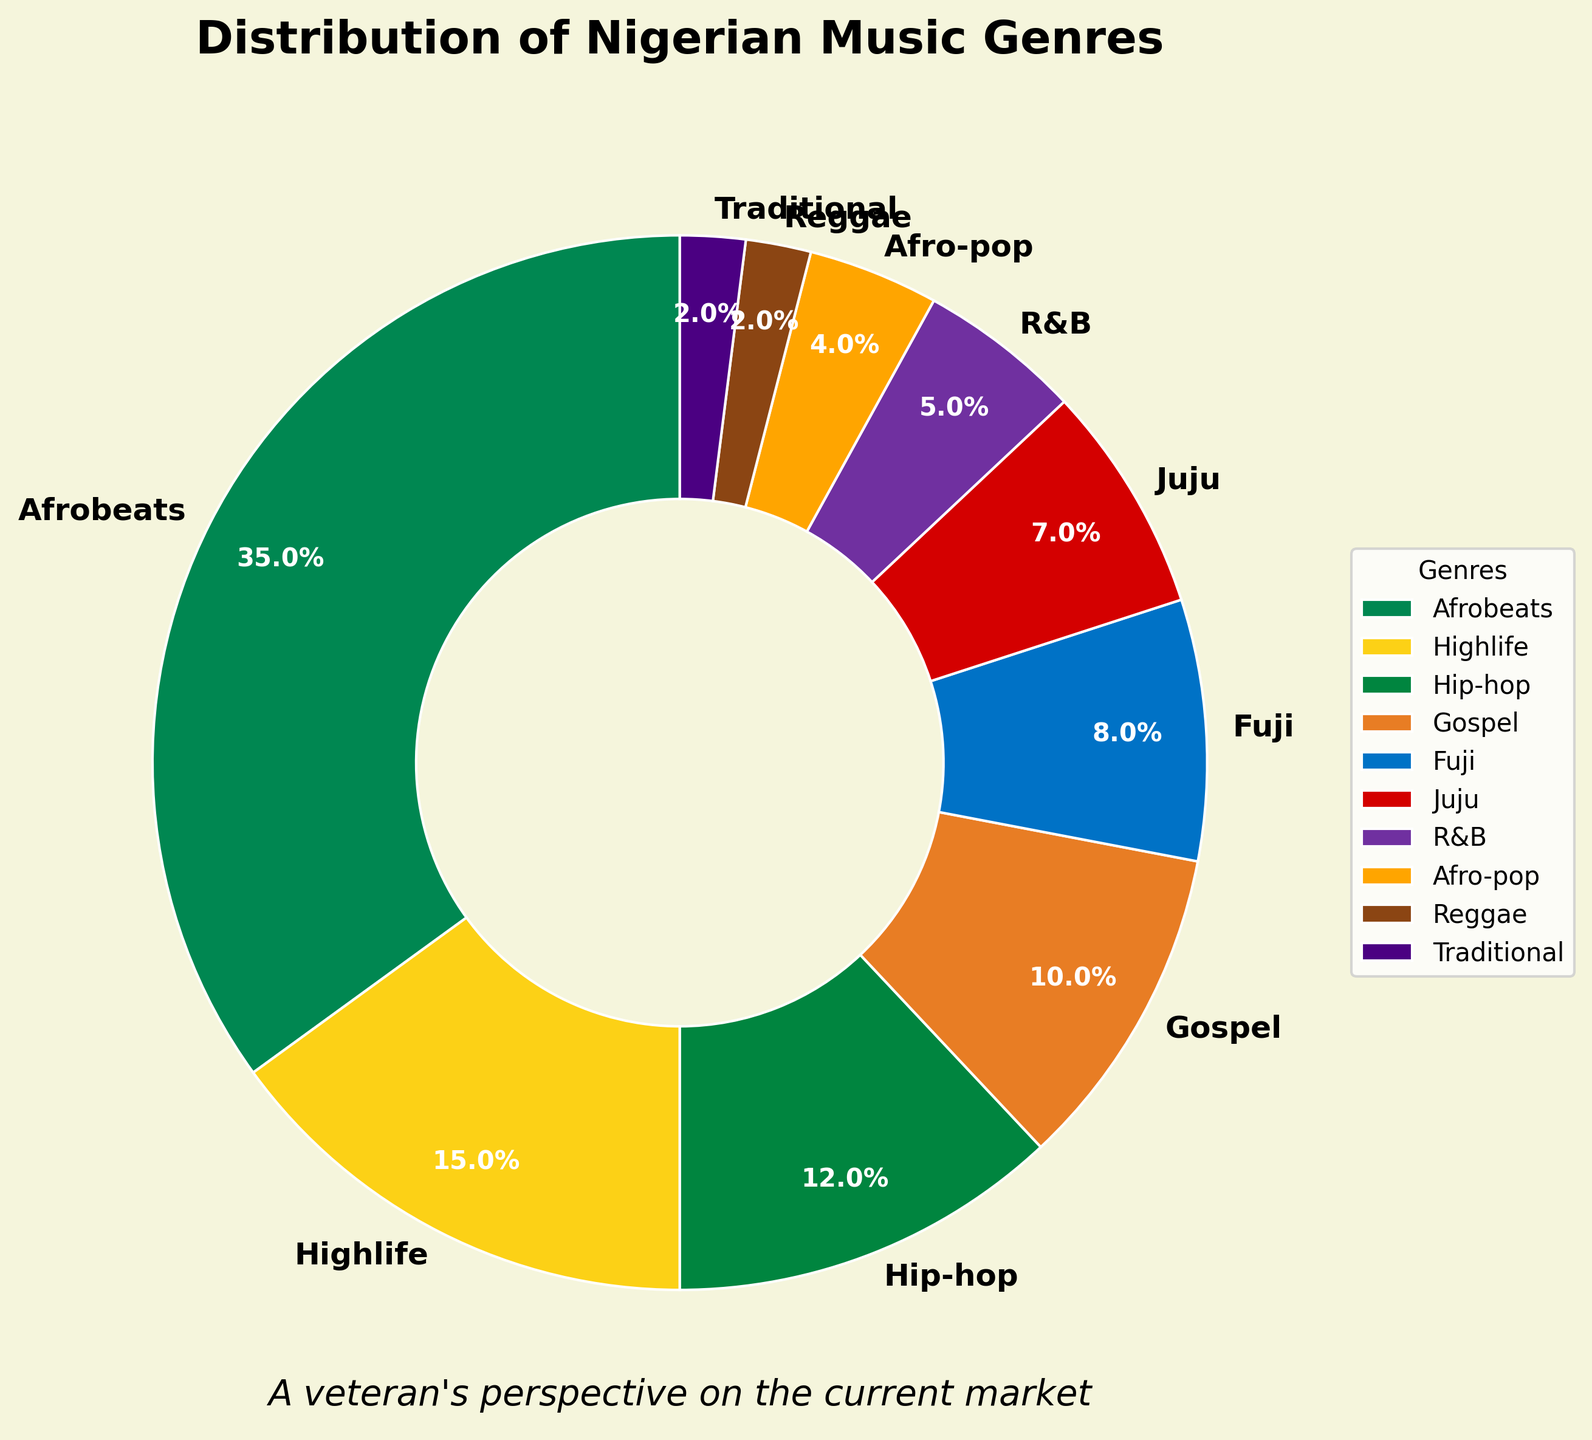Which genre has the largest share in the current Nigerian music market? The slice representing Afrobeats is the largest in the pie chart.
Answer: Afrobeats What is the combined percentage of Highlife, Hip-hop, and Gospel music genres? Sum the percentages of Highlife (15%), Hip-hop (12%), and Gospel (10%): 15 + 12 + 10 = 37
Answer: 37% Which genre has a greater market share, Fuji or Juju? Compare the slices representing Fuji and Juju. Fuji has 8%, while Juju has 7%.
Answer: Fuji How many genres have a market share of 10% or less? Identify slices with percentages up to 10%: Hip-hop (12%), Gospel (10%), Fuji (8%), Juju (7%), R&B (5%), Afro-pop (4%), Reggae (2%), Traditional (2%).
Answer: 7 What is the difference in percentage between the most popular genre and the least popular genre? The most popular genre (Afrobeats) is 35%, and the least popular genres (Reggae and Traditional) are 2%. Difference: 35 - 2 = 33
Answer: 33% Which genres are represented by the green and yellow slices? Identify the colors used for the slices. Green represents Highlife and yellow represents Afro-pop.
Answer: Highlife and Afro-pop What genres make up less than 5% of the market? Identify slices with percentages less than 5%: Afro-pop (4%), Reggae (2%), Traditional (2%).
Answer: Afro-pop, Reggae, Traditional Are there more genres with a market share above 10% or below 10%? Genres above 10%: Afrobeats, Highlife, Hip-hop. Genres below 10%: Gospel, Fuji, Juju, R&B, Afro-pop, Reggae, Traditional. Compare counts: 3 vs. 7.
Answer: Below 10% How does the share of R&B compare to the combined share of Reggae and Traditional? R&B is 5%. Reggae and Traditional combined is 2% + 2% = 4%.
Answer: R&B is higher 